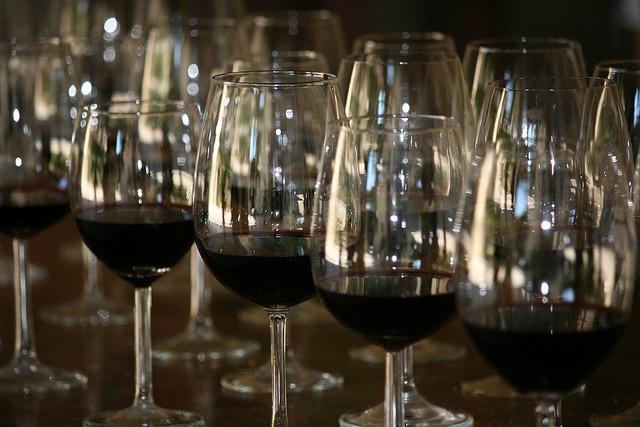How many wine glasses are there?
Give a very brief answer. 11. 